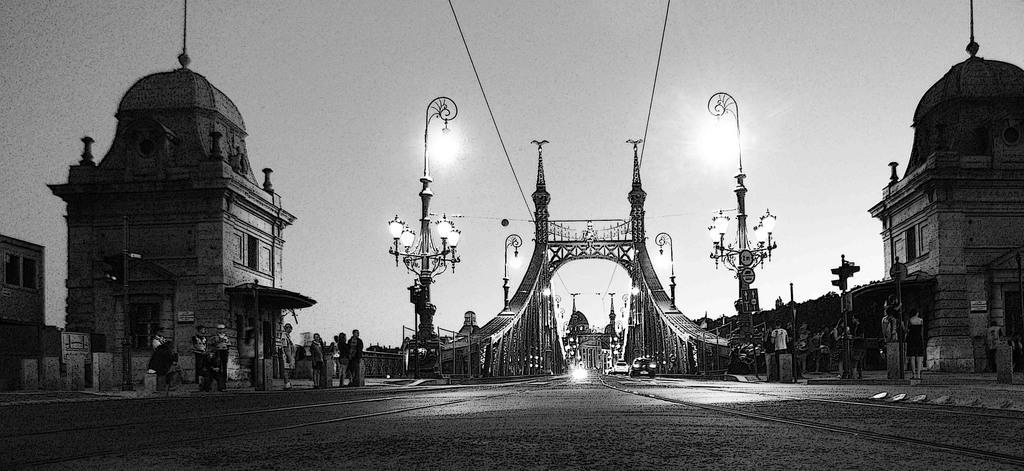In one or two sentences, can you explain what this image depicts? In the image in the center, we can see one bridge. And we can see poles, lights, banners, sign boards and few people are standing. And we can see a few vehicles on the road. In the background we can see the sky, buildings etc. 